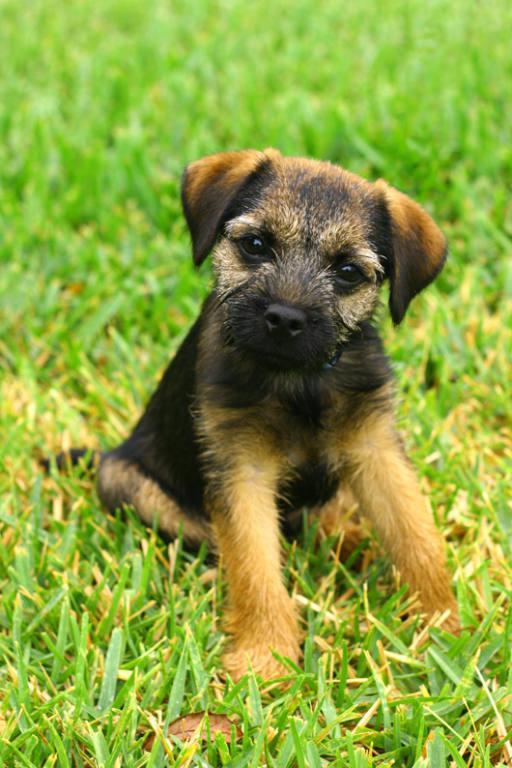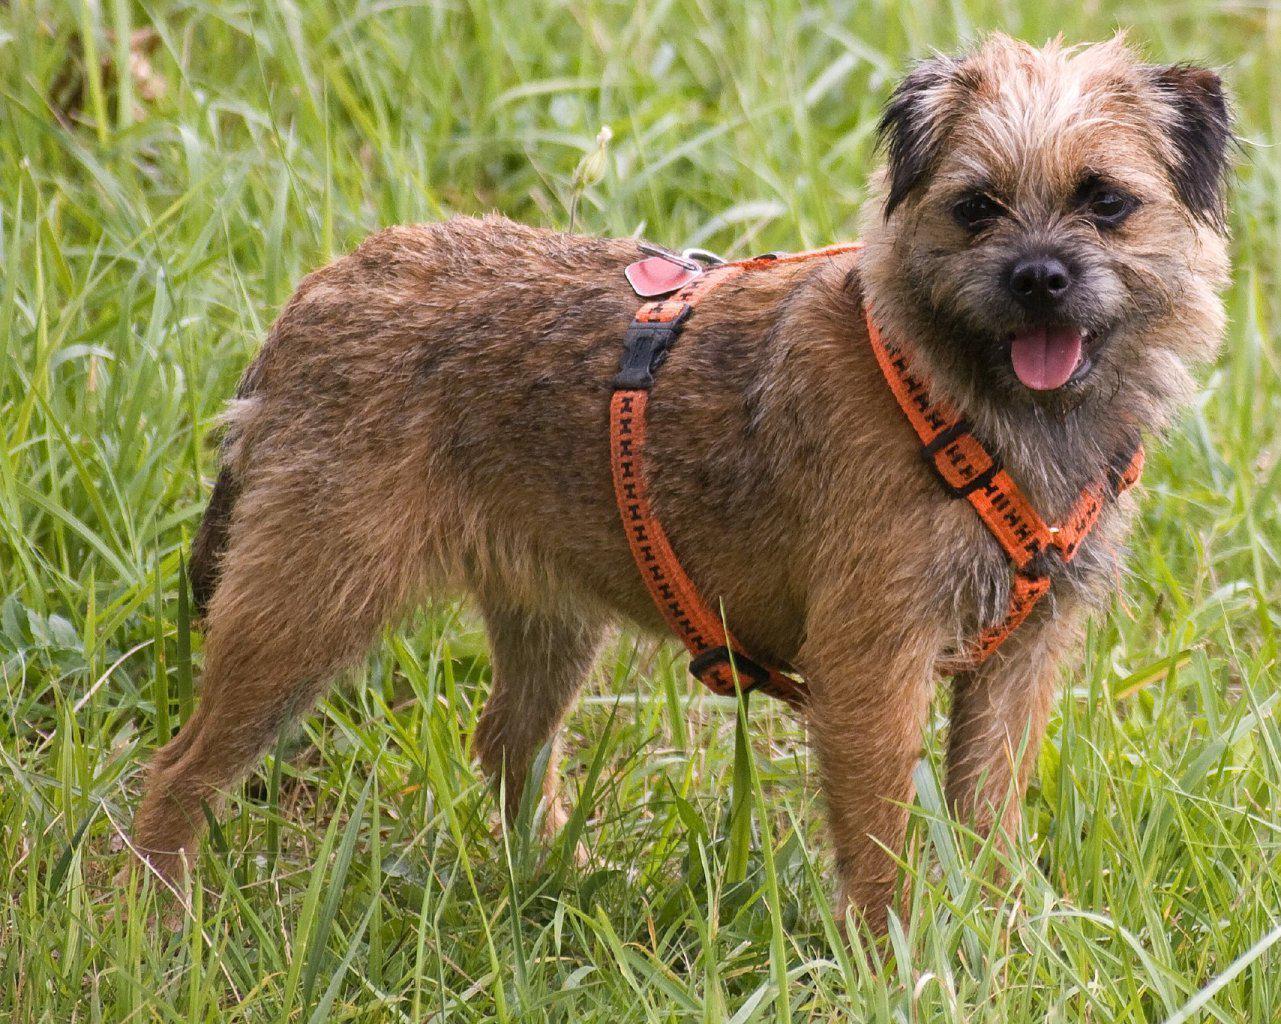The first image is the image on the left, the second image is the image on the right. Examine the images to the left and right. Is the description "the dog in the image on the right is standing on all fours" accurate? Answer yes or no. Yes. 